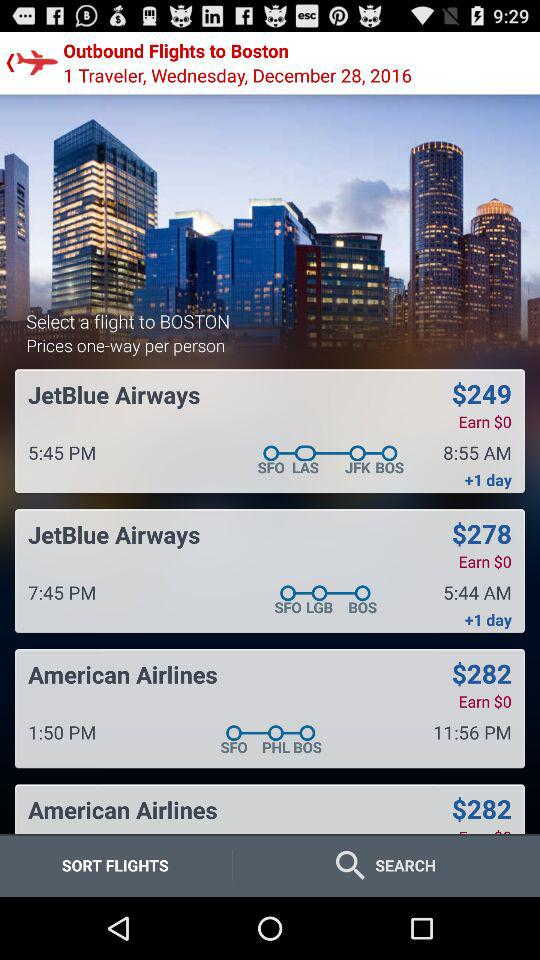What is the number of travelers? The number of travelers is 1. 